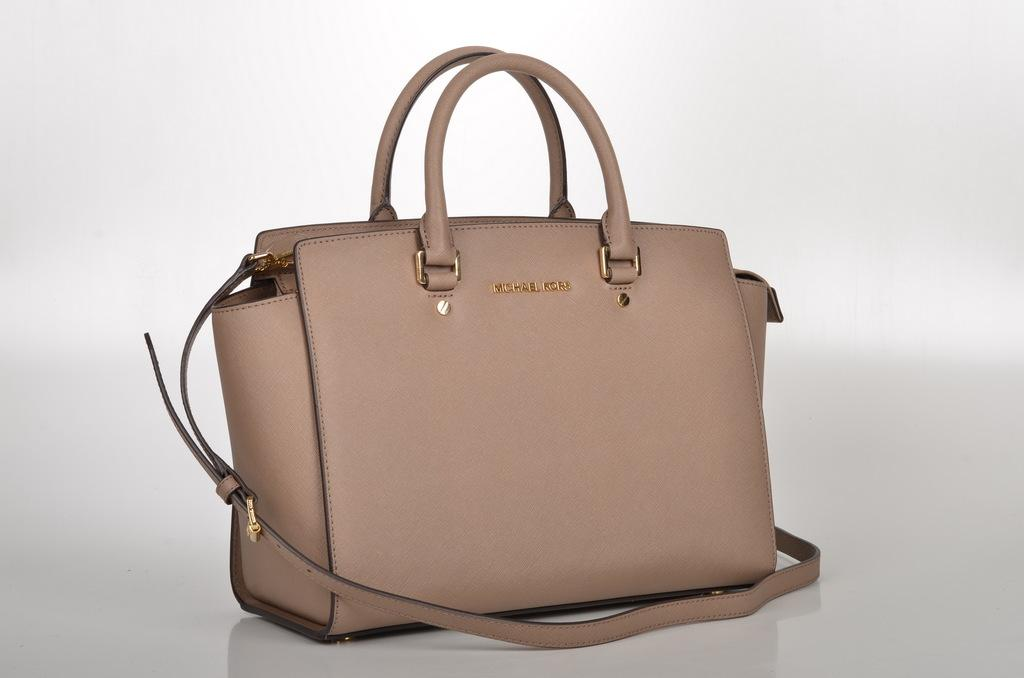What is the main object in the image? There is a handbag in the image. How many owls are sitting on the handbag in the image? There are no owls present in the image; it only features a handbag. What shape is the handbag in the image? The shape of the handbag cannot be determined from the provided information, as only the fact that there is a handbag is mentioned. 